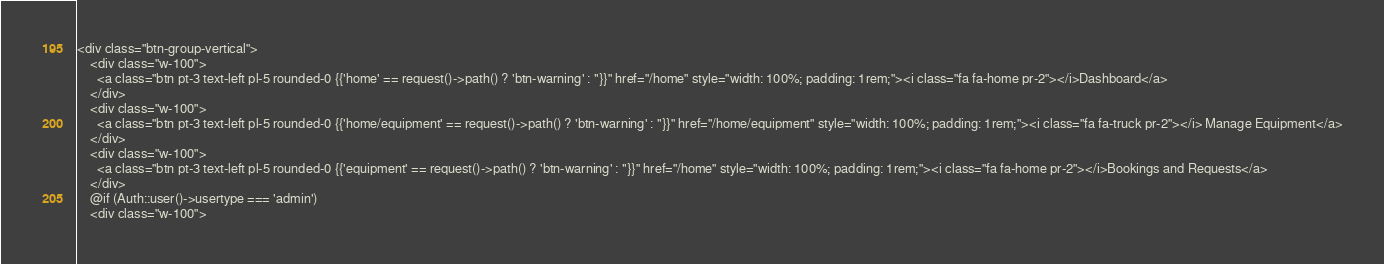<code> <loc_0><loc_0><loc_500><loc_500><_PHP_><div class="btn-group-vertical">
    <div class="w-100">
      <a class="btn pt-3 text-left pl-5 rounded-0 {{'home' == request()->path() ? 'btn-warning' : ''}}" href="/home" style="width: 100%; padding: 1rem;"><i class="fa fa-home pr-2"></i>Dashboard</a>
    </div>
    <div class="w-100">
      <a class="btn pt-3 text-left pl-5 rounded-0 {{'home/equipment' == request()->path() ? 'btn-warning' : ''}}" href="/home/equipment" style="width: 100%; padding: 1rem;"><i class="fa fa-truck pr-2"></i> Manage Equipment</a>
    </div>
    <div class="w-100">
      <a class="btn pt-3 text-left pl-5 rounded-0 {{'equipment' == request()->path() ? 'btn-warning' : ''}}" href="/home" style="width: 100%; padding: 1rem;"><i class="fa fa-home pr-2"></i>Bookings and Requests</a>
    </div>
    @if (Auth::user()->usertype === 'admin')
    <div class="w-100"></code> 